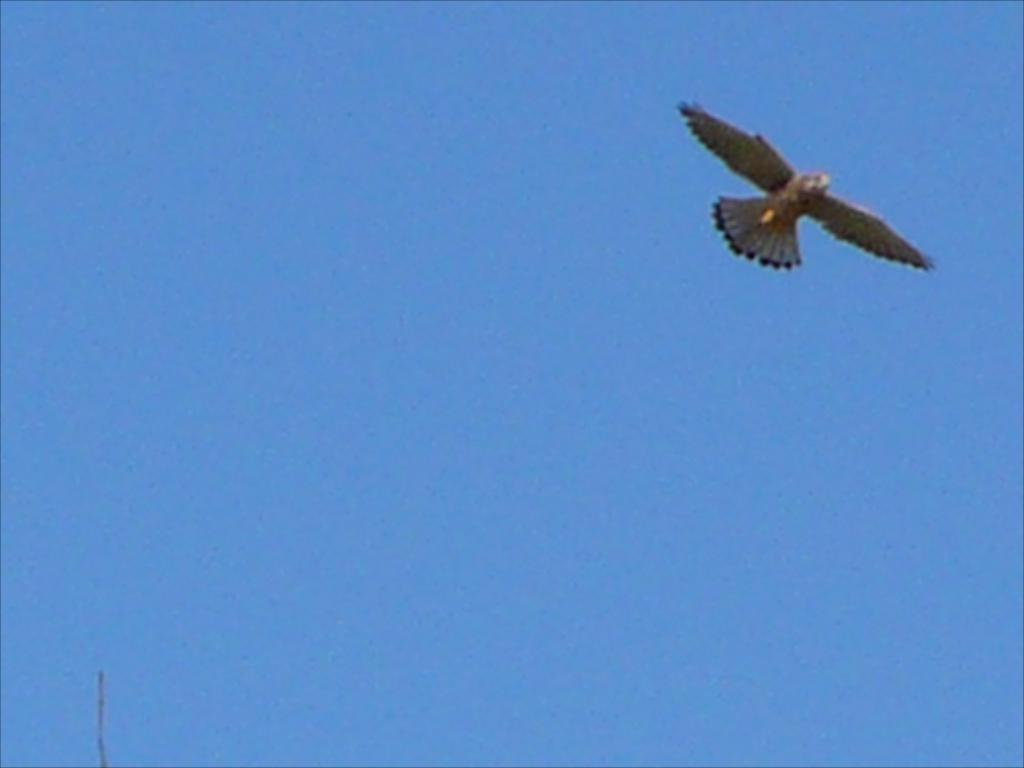What type of animal can be seen in the image? There is a bird in the image. What is the bird doing in the image? The bird is flying in the sky. How does the bird contribute to the division of trees in the image? There are no trees present in the image, and the bird is not dividing anything. 